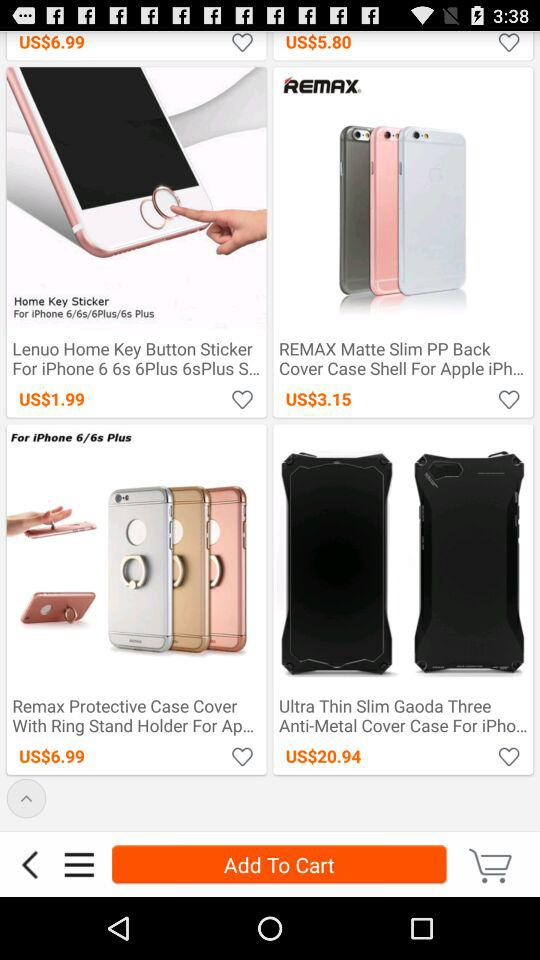What is the price of "Remax Protective Case Cover With Ring Stand Holder For Ap..."? The price is US$6.99. 